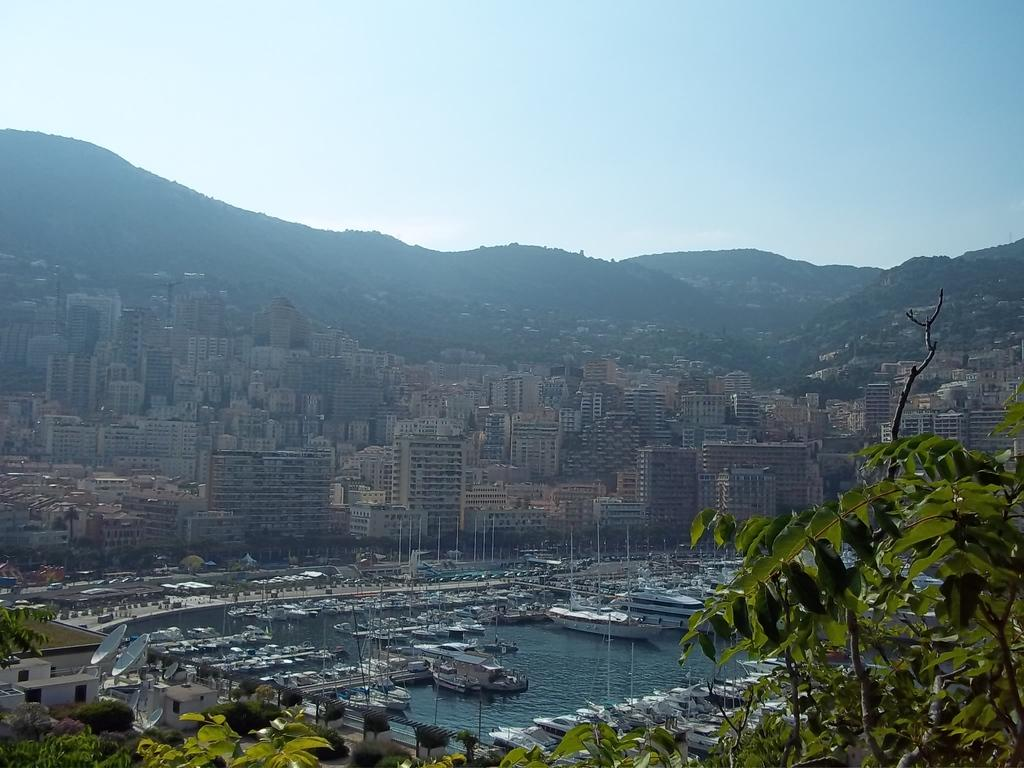What type of vehicles can be seen in the image? There are boats in the image. What color are the boats? The boats are white in color. What is the primary element in which the boats are situated? There is water in the image, and the boats are situated in it. What can be seen in the background of the image? There are buildings, trees with green leaves, and mountains in the background of the image. What is the color of the sky in the image? The sky is visible in the image and appears to be white. How many times did the person cough while taking the image? There is no information about a person coughing while taking the image, so it cannot be determined. 